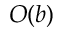<formula> <loc_0><loc_0><loc_500><loc_500>O ( b )</formula> 